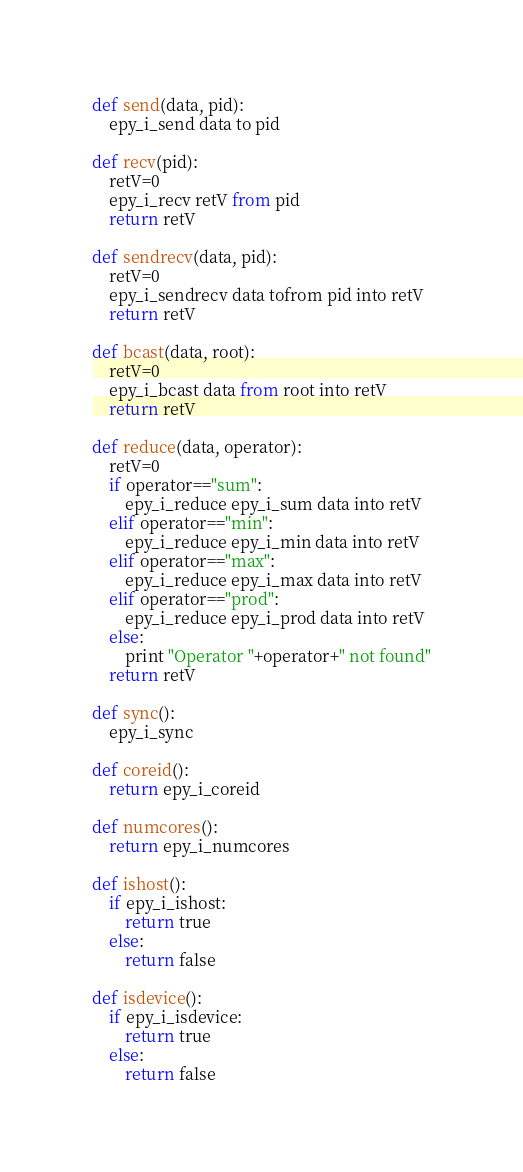<code> <loc_0><loc_0><loc_500><loc_500><_Python_>def send(data, pid):
	epy_i_send data to pid

def recv(pid):
	retV=0
	epy_i_recv retV from pid
	return retV

def sendrecv(data, pid):
	retV=0
	epy_i_sendrecv data tofrom pid into retV
	return retV

def bcast(data, root):
	retV=0
	epy_i_bcast data from root into retV
	return retV

def reduce(data, operator):
	retV=0
	if operator=="sum":
		epy_i_reduce epy_i_sum data into retV
	elif operator=="min":
		epy_i_reduce epy_i_min data into retV
	elif operator=="max":
		epy_i_reduce epy_i_max data into retV
	elif operator=="prod":
		epy_i_reduce epy_i_prod data into retV
	else:
		print "Operator "+operator+" not found"
	return retV

def sync():
	epy_i_sync

def coreid():
	return epy_i_coreid

def numcores():
	return epy_i_numcores

def ishost():
	if epy_i_ishost:
		return true
	else:
		return false

def isdevice():
	if epy_i_isdevice:
		return true
	else:
		return false</code> 